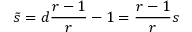<formula> <loc_0><loc_0><loc_500><loc_500>\tilde { s } = d \frac { r - 1 } { r } - 1 = \frac { r - 1 } { r } s</formula> 